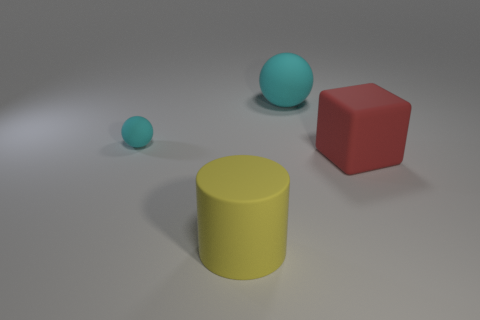Add 1 cubes. How many objects exist? 5 Subtract 0 blue balls. How many objects are left? 4 Subtract all blocks. How many objects are left? 3 Subtract all brown cylinders. Subtract all purple balls. How many cylinders are left? 1 Subtract all blue cubes. How many gray spheres are left? 0 Subtract all large brown matte balls. Subtract all cyan matte things. How many objects are left? 2 Add 1 small objects. How many small objects are left? 2 Add 3 tiny matte objects. How many tiny matte objects exist? 4 